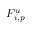<formula> <loc_0><loc_0><loc_500><loc_500>F _ { i , p } ^ { u }</formula> 